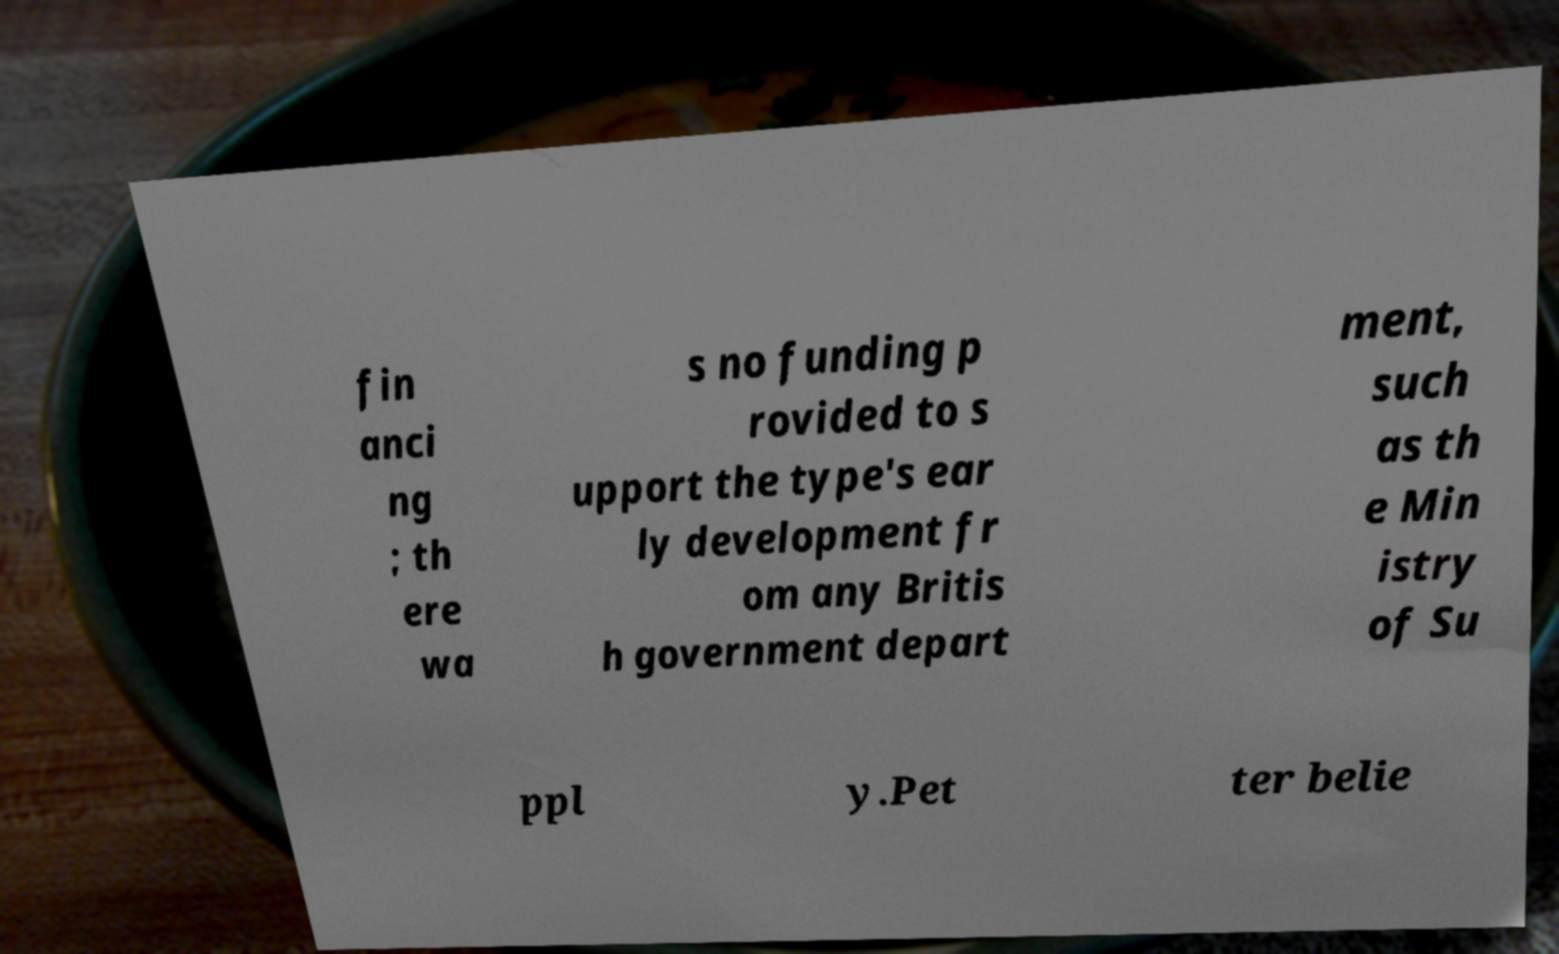What messages or text are displayed in this image? I need them in a readable, typed format. fin anci ng ; th ere wa s no funding p rovided to s upport the type's ear ly development fr om any Britis h government depart ment, such as th e Min istry of Su ppl y.Pet ter belie 